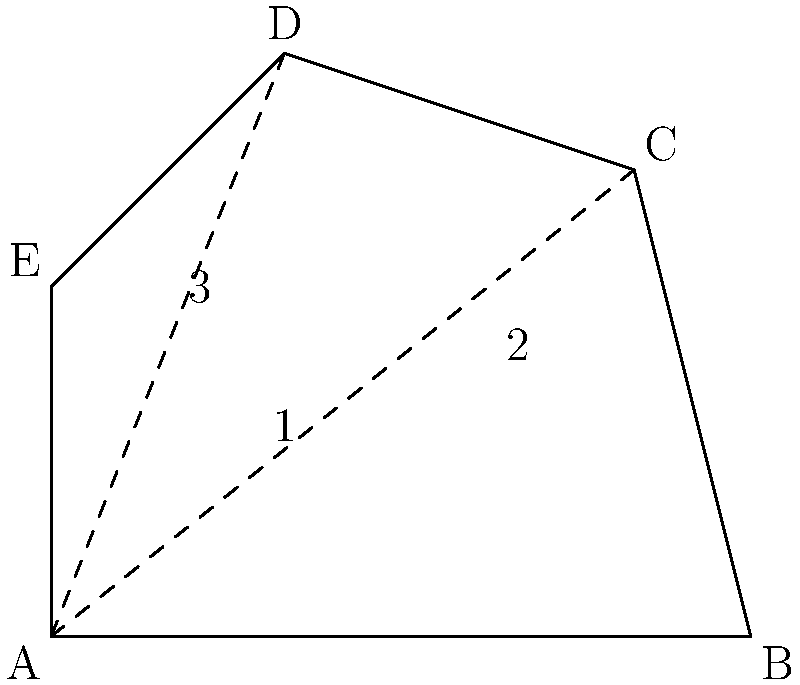Given the complex polygon ABCDE shown in the figure, calculate its area using triangulation. Assume the coordinates of the vertices are A(0,0), B(6,0), C(5,4), D(2,5), and E(0,3). How does this triangulation method relate to mesh processing in 3D models? To calculate the area of the complex polygon ABCDE using triangulation:

1. Divide the polygon into triangles:
   - Triangle 1: ABC
   - Triangle 2: ACD
   - Triangle 3: ADE

2. Calculate the area of each triangle using the formula:
   $$\text{Area} = \frac{1}{2}|\text{det}(\vec{v_1}, \vec{v_2})|$$
   where $\vec{v_1}$ and $\vec{v_2}$ are vectors representing two sides of the triangle.

3. For Triangle 1 (ABC):
   $\vec{v_1} = (6,0)$, $\vec{v_2} = (5,4)$
   $$\text{Area}_1 = \frac{1}{2}|\text{det}((6,0), (5,4))| = \frac{1}{2}|24| = 12$$

4. For Triangle 2 (ACD):
   $\vec{v_1} = (5,4)$, $\vec{v_2} = (2,5)$
   $$\text{Area}_2 = \frac{1}{2}|\text{det}((5,4), (2,5))| = \frac{1}{2}|17| = 8.5$$

5. For Triangle 3 (ADE):
   $\vec{v_1} = (2,5)$, $\vec{v_2} = (0,3)$
   $$\text{Area}_3 = \frac{1}{2}|\text{det}((2,5), (0,3))| = \frac{1}{2}|6| = 3$$

6. Sum up the areas of all triangles:
   $$\text{Total Area} = 12 + 8.5 + 3 = 23.5$$

Relation to mesh processing in 3D models:
This triangulation method is fundamental in 3D mesh processing. In 3D models, complex surfaces are often represented as a collection of triangles (triangular mesh). The process of breaking down a complex polygon into triangles is analogous to creating a mesh for a 3D surface. This allows for efficient storage, rendering, and manipulation of 3D objects in computer graphics and real-time rendering applications. Understanding and implementing such triangulation techniques is crucial for optimizing mesh representations and improving rendering performance in 3D graphics pipelines.
Answer: 23.5 square units 